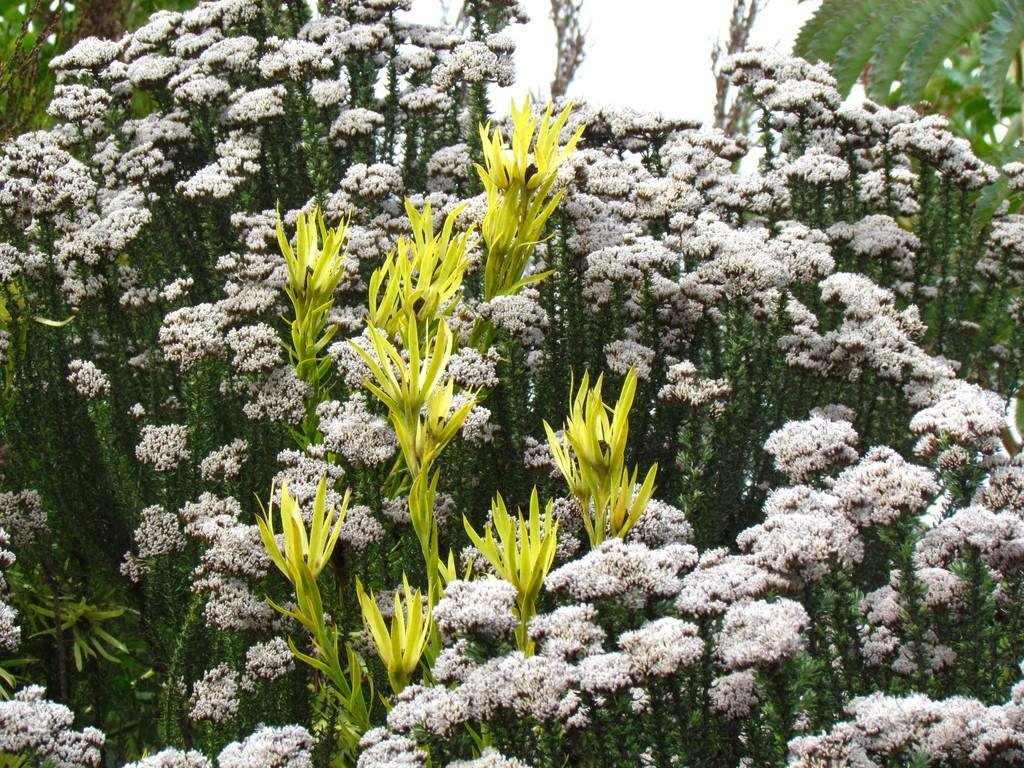What type of plant is present in the image? There are flowers on the plant in the image. What can be seen at the top of the image? The sky is visible at the top of the image. What is located on the right side of the image? There are leaves on the right side of the image. What type of lunch is being served on the table in the image? There is no table or lunch present in the image; it only features a plant with flowers and leaves. Can you describe the chin of the person in the image? There is no person present in the image, so it is not possible to describe their chin. 